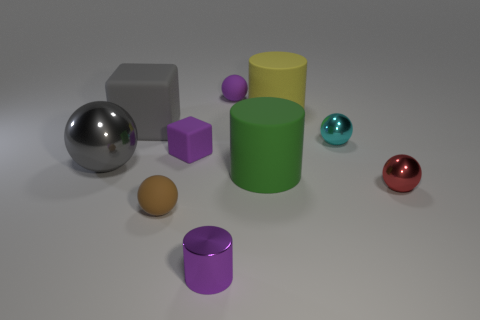Does the big rubber block have the same color as the large metallic thing?
Make the answer very short. Yes. Do the small cylinder that is on the left side of the large green rubber cylinder and the big gray object that is behind the big metallic ball have the same material?
Offer a terse response. No. Are there any other things of the same size as the purple metallic object?
Give a very brief answer. Yes. What is the size of the shiny sphere that is on the left side of the object in front of the brown matte sphere?
Your answer should be very brief. Large. What number of large spheres have the same color as the big metallic object?
Make the answer very short. 0. There is a purple rubber thing that is left of the metallic thing that is in front of the brown rubber object; what is its shape?
Offer a very short reply. Cube. How many small cubes are made of the same material as the large sphere?
Offer a terse response. 0. There is a tiny purple object that is in front of the small red thing; what is it made of?
Ensure brevity in your answer.  Metal. There is a tiny thing that is in front of the tiny rubber object that is in front of the metallic ball in front of the green matte cylinder; what shape is it?
Provide a short and direct response. Cylinder. Does the shiny thing that is behind the big gray metallic ball have the same color as the tiny matte sphere that is in front of the tiny purple rubber block?
Offer a very short reply. No. 